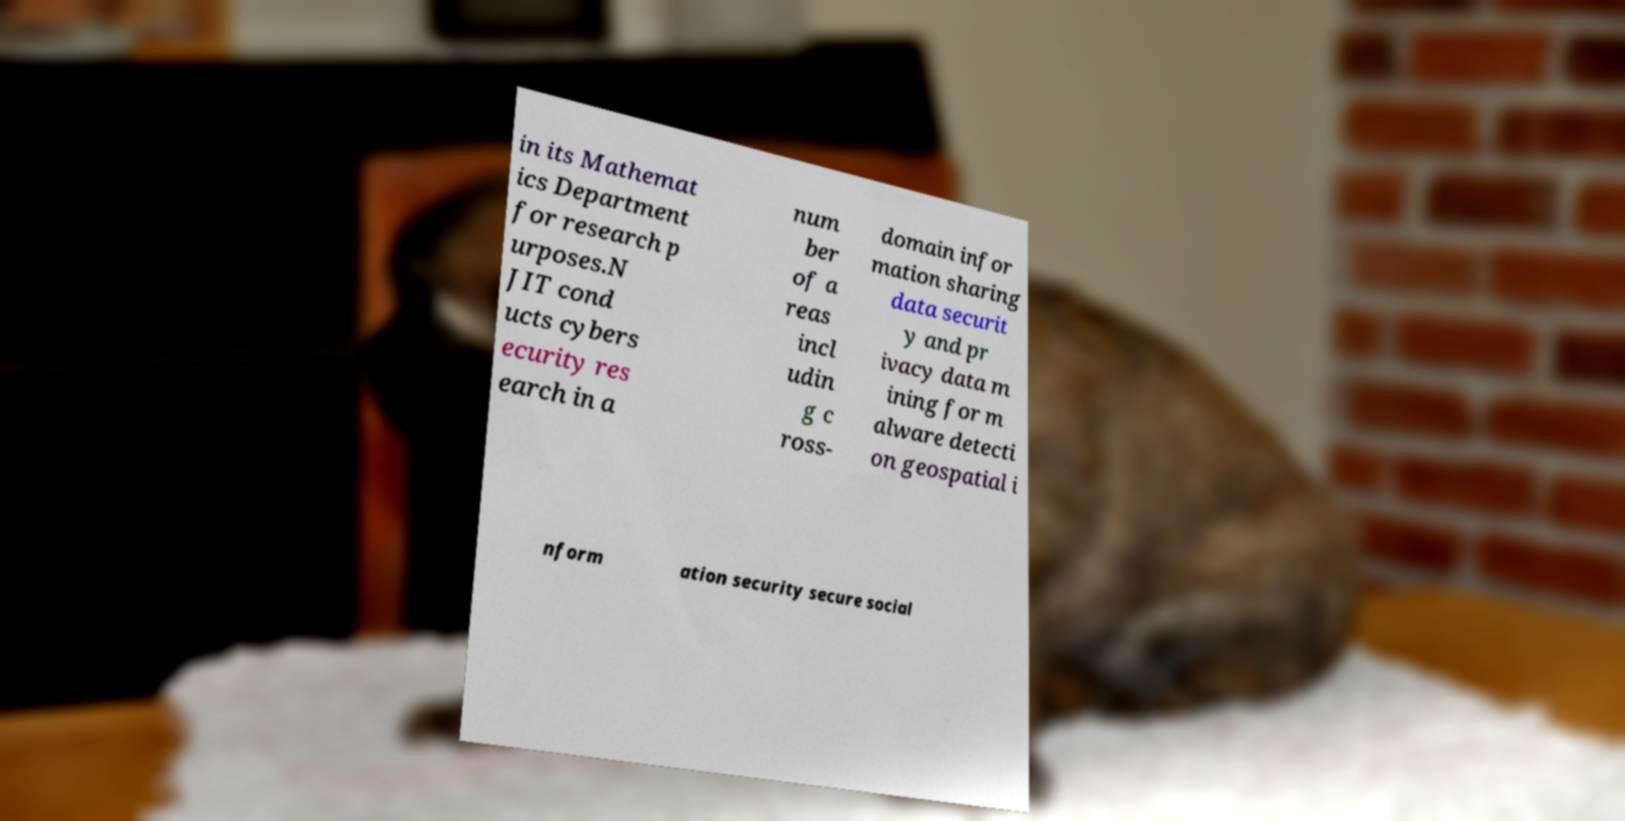What messages or text are displayed in this image? I need them in a readable, typed format. in its Mathemat ics Department for research p urposes.N JIT cond ucts cybers ecurity res earch in a num ber of a reas incl udin g c ross- domain infor mation sharing data securit y and pr ivacy data m ining for m alware detecti on geospatial i nform ation security secure social 